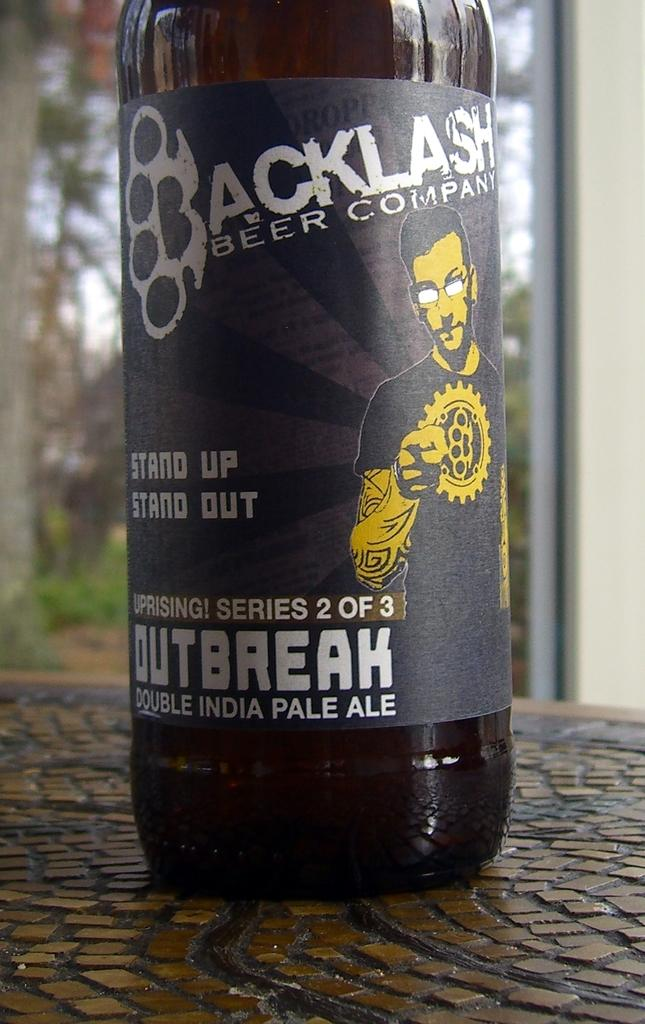Provide a one-sentence caption for the provided image. Uprising! Series 2 out of 3 bottle of Outbreak double India pale ale sitting on a table. 